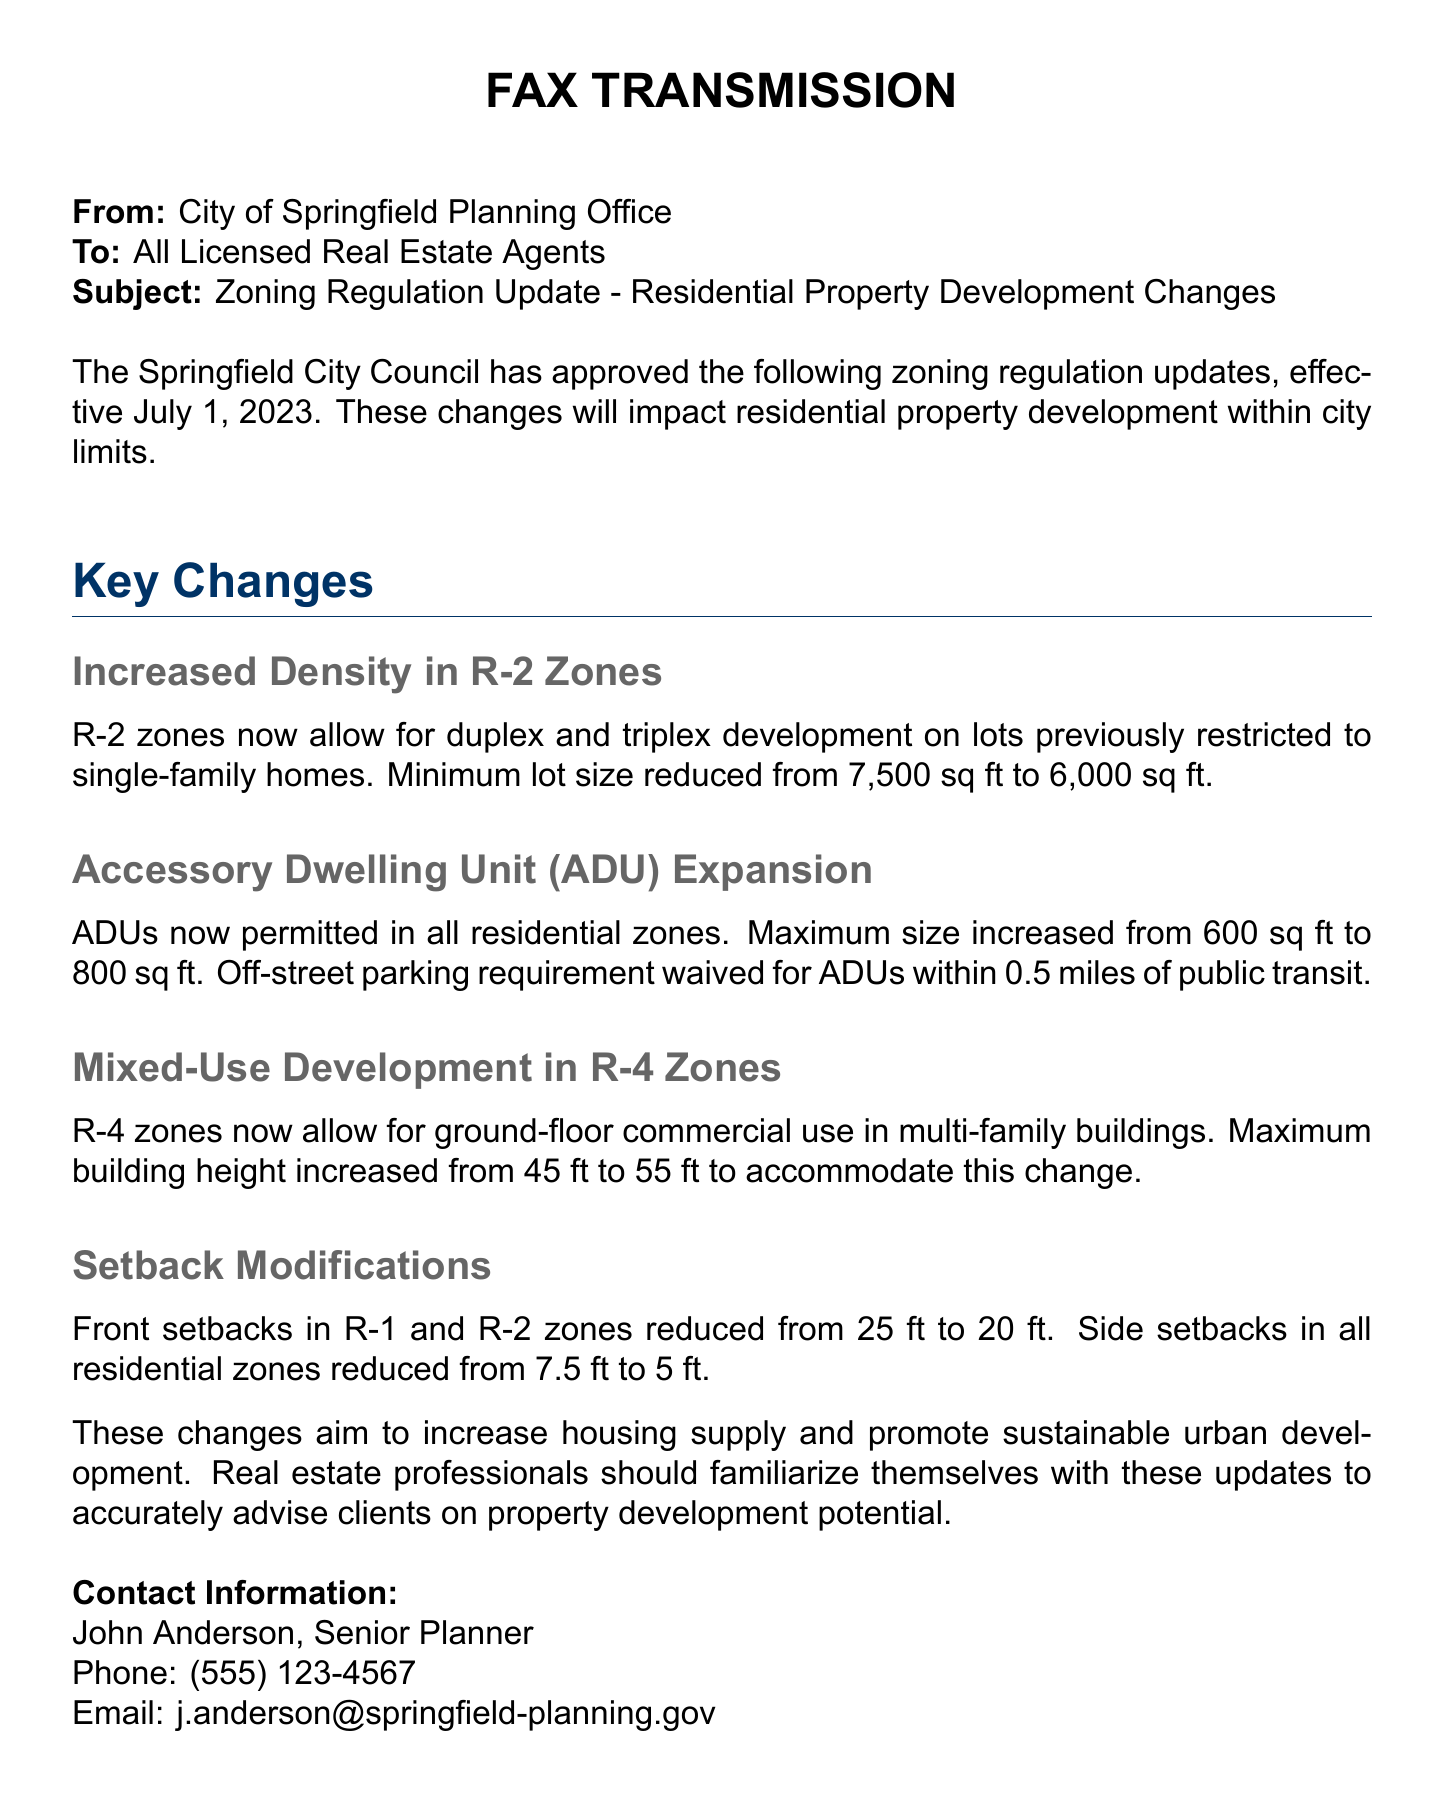What is the effective date of the zoning regulation updates? The effective date is mentioned in the document as July 1, 2023.
Answer: July 1, 2023 What is the new minimum lot size for duplex and triplex development in R-2 zones? The new minimum lot size for duplex and triplex development in R-2 zones has been reduced from 7,500 sq ft to 6,000 sq ft.
Answer: 6,000 sq ft What is the maximum size permitted for Accessory Dwelling Units (ADUs) after the update? The maximum size for ADUs was increased from 600 sq ft to 800 sq ft according to the updates.
Answer: 800 sq ft What setback is required in R-1 and R-2 zones after the modification? The front setbacks in R-1 and R-2 zones were reduced from 25 ft to 20 ft.
Answer: 20 ft Which planning official's contact information is provided in the document? The document provides the contact information for John Anderson, who is the Senior Planner.
Answer: John Anderson How much has the maximum building height increased for mixed-use development in R-4 zones? The maximum building height for mixed-use development in R-4 zones has increased from 45 ft to 55 ft.
Answer: 10 ft Which requirement for ADUs has been waived if they are within 0.5 miles of public transit? The off-street parking requirement has been waived for ADUs within 0.5 miles of public transit.
Answer: Off-street parking requirement What was the side setback reduction in all residential zones? The side setbacks in all residential zones were reduced from 7.5 ft to 5 ft.
Answer: 5 ft 